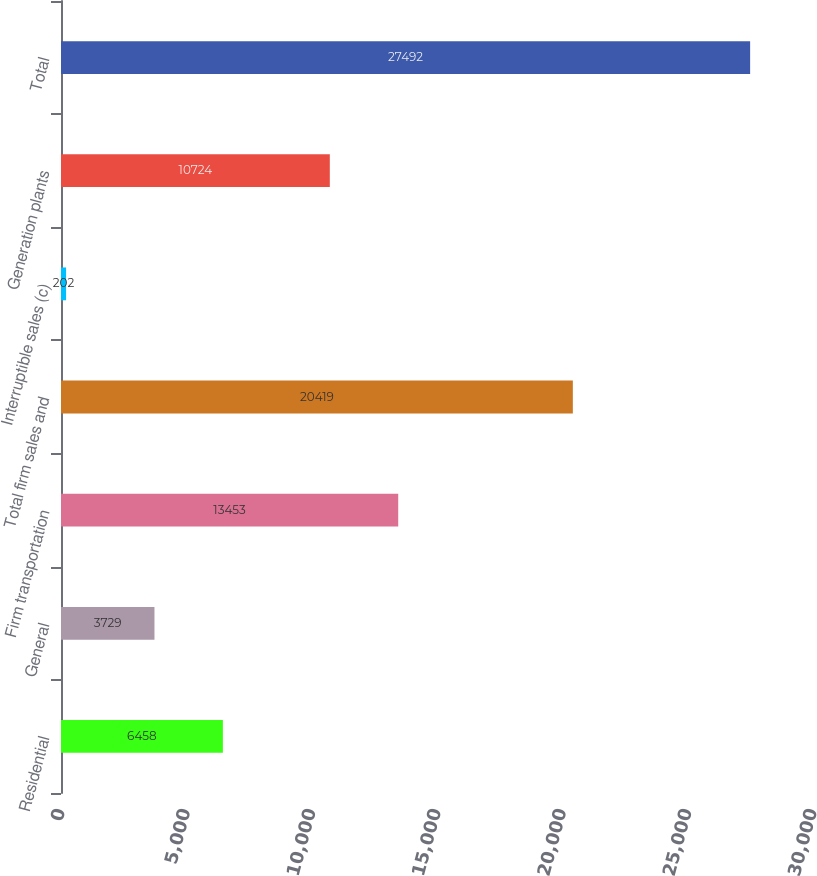Convert chart. <chart><loc_0><loc_0><loc_500><loc_500><bar_chart><fcel>Residential<fcel>General<fcel>Firm transportation<fcel>Total firm sales and<fcel>Interruptible sales (c)<fcel>Generation plants<fcel>Total<nl><fcel>6458<fcel>3729<fcel>13453<fcel>20419<fcel>202<fcel>10724<fcel>27492<nl></chart> 